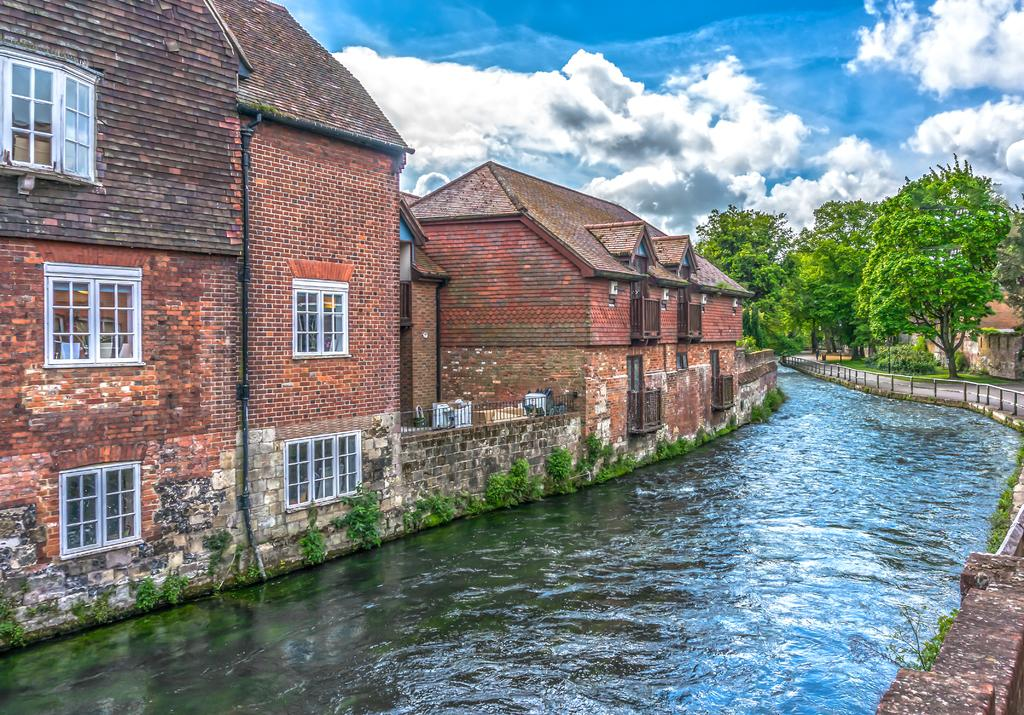What is the main feature of the image? The main feature of the image is water flowing. What type of structures can be seen in the image? There are brick buildings in the image. What other natural elements are present in the image? There are trees in the image. What is the condition of the fence in the image? The fence is present in the image. How would you describe the sky in the image? The sky is blue with clouds in the background. How much honey is being smashed by the trees in the image? There is no honey or smashing activity present in the image. The image features water flowing, brick buildings, trees, a fence, and a blue sky with clouds. 